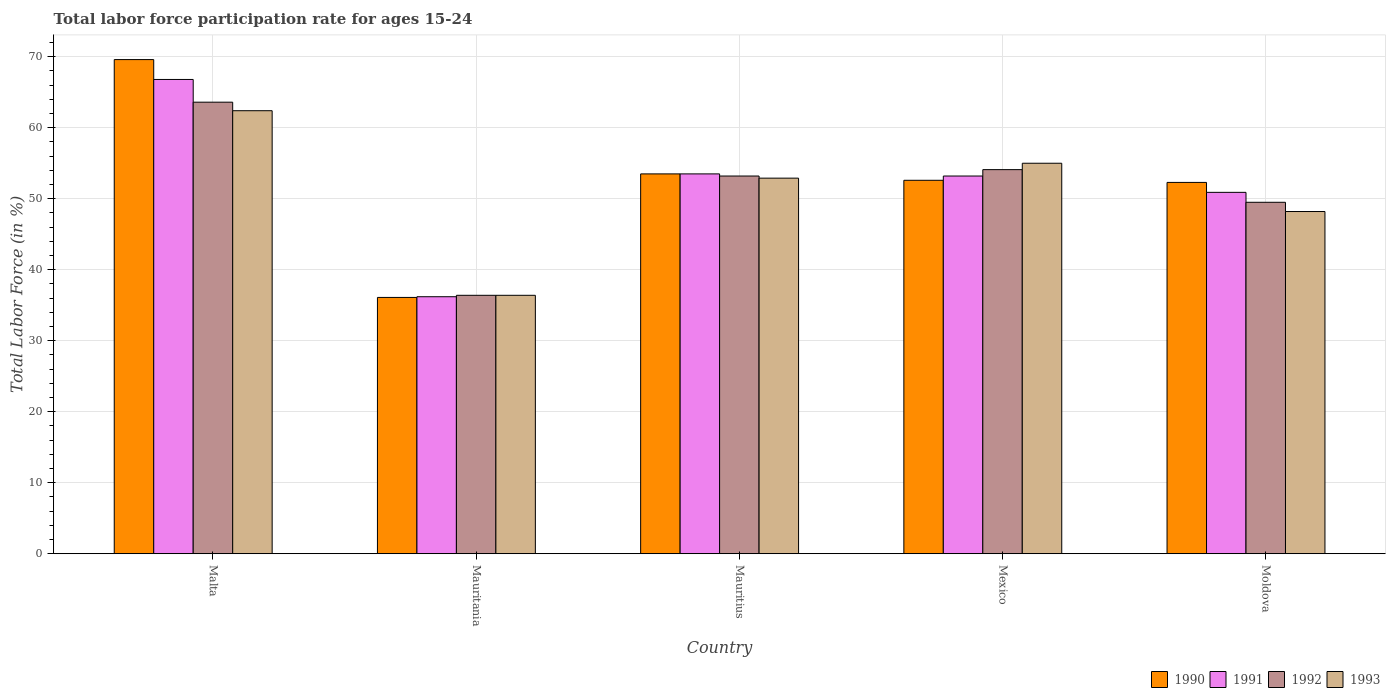How many groups of bars are there?
Ensure brevity in your answer.  5. Are the number of bars per tick equal to the number of legend labels?
Your answer should be compact. Yes. How many bars are there on the 3rd tick from the right?
Offer a very short reply. 4. What is the label of the 1st group of bars from the left?
Keep it short and to the point. Malta. In how many cases, is the number of bars for a given country not equal to the number of legend labels?
Provide a succinct answer. 0. What is the labor force participation rate in 1990 in Mauritius?
Your answer should be compact. 53.5. Across all countries, what is the maximum labor force participation rate in 1990?
Make the answer very short. 69.6. Across all countries, what is the minimum labor force participation rate in 1991?
Provide a short and direct response. 36.2. In which country was the labor force participation rate in 1990 maximum?
Keep it short and to the point. Malta. In which country was the labor force participation rate in 1992 minimum?
Provide a succinct answer. Mauritania. What is the total labor force participation rate in 1991 in the graph?
Provide a short and direct response. 260.6. What is the difference between the labor force participation rate in 1991 in Mauritania and that in Mexico?
Offer a very short reply. -17. What is the average labor force participation rate in 1993 per country?
Offer a very short reply. 50.98. What is the difference between the labor force participation rate of/in 1992 and labor force participation rate of/in 1990 in Mauritius?
Give a very brief answer. -0.3. What is the ratio of the labor force participation rate in 1993 in Malta to that in Mauritius?
Your answer should be very brief. 1.18. Is the labor force participation rate in 1993 in Malta less than that in Mauritania?
Offer a very short reply. No. Is the difference between the labor force participation rate in 1992 in Mauritius and Moldova greater than the difference between the labor force participation rate in 1990 in Mauritius and Moldova?
Provide a succinct answer. Yes. What is the difference between the highest and the second highest labor force participation rate in 1990?
Your answer should be compact. 0.9. Is it the case that in every country, the sum of the labor force participation rate in 1991 and labor force participation rate in 1990 is greater than the labor force participation rate in 1992?
Your answer should be compact. Yes. How many bars are there?
Provide a succinct answer. 20. Are all the bars in the graph horizontal?
Provide a succinct answer. No. How many countries are there in the graph?
Keep it short and to the point. 5. What is the difference between two consecutive major ticks on the Y-axis?
Provide a short and direct response. 10. Are the values on the major ticks of Y-axis written in scientific E-notation?
Make the answer very short. No. Does the graph contain any zero values?
Keep it short and to the point. No. Where does the legend appear in the graph?
Make the answer very short. Bottom right. What is the title of the graph?
Offer a very short reply. Total labor force participation rate for ages 15-24. Does "1964" appear as one of the legend labels in the graph?
Give a very brief answer. No. What is the Total Labor Force (in %) of 1990 in Malta?
Provide a succinct answer. 69.6. What is the Total Labor Force (in %) of 1991 in Malta?
Your answer should be very brief. 66.8. What is the Total Labor Force (in %) of 1992 in Malta?
Offer a terse response. 63.6. What is the Total Labor Force (in %) of 1993 in Malta?
Give a very brief answer. 62.4. What is the Total Labor Force (in %) of 1990 in Mauritania?
Ensure brevity in your answer.  36.1. What is the Total Labor Force (in %) in 1991 in Mauritania?
Offer a terse response. 36.2. What is the Total Labor Force (in %) of 1992 in Mauritania?
Provide a short and direct response. 36.4. What is the Total Labor Force (in %) in 1993 in Mauritania?
Your answer should be compact. 36.4. What is the Total Labor Force (in %) of 1990 in Mauritius?
Provide a short and direct response. 53.5. What is the Total Labor Force (in %) of 1991 in Mauritius?
Your answer should be compact. 53.5. What is the Total Labor Force (in %) of 1992 in Mauritius?
Offer a terse response. 53.2. What is the Total Labor Force (in %) in 1993 in Mauritius?
Offer a very short reply. 52.9. What is the Total Labor Force (in %) of 1990 in Mexico?
Ensure brevity in your answer.  52.6. What is the Total Labor Force (in %) of 1991 in Mexico?
Give a very brief answer. 53.2. What is the Total Labor Force (in %) in 1992 in Mexico?
Make the answer very short. 54.1. What is the Total Labor Force (in %) of 1993 in Mexico?
Your answer should be very brief. 55. What is the Total Labor Force (in %) of 1990 in Moldova?
Your answer should be very brief. 52.3. What is the Total Labor Force (in %) of 1991 in Moldova?
Make the answer very short. 50.9. What is the Total Labor Force (in %) in 1992 in Moldova?
Offer a terse response. 49.5. What is the Total Labor Force (in %) of 1993 in Moldova?
Your answer should be compact. 48.2. Across all countries, what is the maximum Total Labor Force (in %) in 1990?
Your answer should be compact. 69.6. Across all countries, what is the maximum Total Labor Force (in %) in 1991?
Offer a very short reply. 66.8. Across all countries, what is the maximum Total Labor Force (in %) of 1992?
Offer a very short reply. 63.6. Across all countries, what is the maximum Total Labor Force (in %) of 1993?
Ensure brevity in your answer.  62.4. Across all countries, what is the minimum Total Labor Force (in %) of 1990?
Provide a short and direct response. 36.1. Across all countries, what is the minimum Total Labor Force (in %) of 1991?
Your answer should be very brief. 36.2. Across all countries, what is the minimum Total Labor Force (in %) in 1992?
Provide a short and direct response. 36.4. Across all countries, what is the minimum Total Labor Force (in %) of 1993?
Offer a very short reply. 36.4. What is the total Total Labor Force (in %) of 1990 in the graph?
Your response must be concise. 264.1. What is the total Total Labor Force (in %) of 1991 in the graph?
Your answer should be compact. 260.6. What is the total Total Labor Force (in %) of 1992 in the graph?
Your answer should be compact. 256.8. What is the total Total Labor Force (in %) in 1993 in the graph?
Provide a succinct answer. 254.9. What is the difference between the Total Labor Force (in %) of 1990 in Malta and that in Mauritania?
Your answer should be very brief. 33.5. What is the difference between the Total Labor Force (in %) of 1991 in Malta and that in Mauritania?
Make the answer very short. 30.6. What is the difference between the Total Labor Force (in %) in 1992 in Malta and that in Mauritania?
Give a very brief answer. 27.2. What is the difference between the Total Labor Force (in %) of 1993 in Malta and that in Mauritania?
Your answer should be very brief. 26. What is the difference between the Total Labor Force (in %) of 1992 in Malta and that in Mauritius?
Provide a succinct answer. 10.4. What is the difference between the Total Labor Force (in %) of 1990 in Malta and that in Mexico?
Offer a very short reply. 17. What is the difference between the Total Labor Force (in %) in 1992 in Malta and that in Mexico?
Give a very brief answer. 9.5. What is the difference between the Total Labor Force (in %) in 1993 in Malta and that in Mexico?
Your answer should be compact. 7.4. What is the difference between the Total Labor Force (in %) in 1990 in Malta and that in Moldova?
Ensure brevity in your answer.  17.3. What is the difference between the Total Labor Force (in %) in 1991 in Malta and that in Moldova?
Give a very brief answer. 15.9. What is the difference between the Total Labor Force (in %) of 1992 in Malta and that in Moldova?
Offer a terse response. 14.1. What is the difference between the Total Labor Force (in %) of 1993 in Malta and that in Moldova?
Make the answer very short. 14.2. What is the difference between the Total Labor Force (in %) in 1990 in Mauritania and that in Mauritius?
Your answer should be very brief. -17.4. What is the difference between the Total Labor Force (in %) in 1991 in Mauritania and that in Mauritius?
Your response must be concise. -17.3. What is the difference between the Total Labor Force (in %) of 1992 in Mauritania and that in Mauritius?
Provide a succinct answer. -16.8. What is the difference between the Total Labor Force (in %) of 1993 in Mauritania and that in Mauritius?
Your answer should be very brief. -16.5. What is the difference between the Total Labor Force (in %) in 1990 in Mauritania and that in Mexico?
Ensure brevity in your answer.  -16.5. What is the difference between the Total Labor Force (in %) in 1992 in Mauritania and that in Mexico?
Keep it short and to the point. -17.7. What is the difference between the Total Labor Force (in %) of 1993 in Mauritania and that in Mexico?
Give a very brief answer. -18.6. What is the difference between the Total Labor Force (in %) of 1990 in Mauritania and that in Moldova?
Your response must be concise. -16.2. What is the difference between the Total Labor Force (in %) of 1991 in Mauritania and that in Moldova?
Ensure brevity in your answer.  -14.7. What is the difference between the Total Labor Force (in %) of 1992 in Mauritania and that in Moldova?
Your answer should be compact. -13.1. What is the difference between the Total Labor Force (in %) in 1993 in Mauritania and that in Moldova?
Your answer should be compact. -11.8. What is the difference between the Total Labor Force (in %) of 1991 in Mauritius and that in Mexico?
Make the answer very short. 0.3. What is the difference between the Total Labor Force (in %) in 1992 in Mauritius and that in Mexico?
Offer a very short reply. -0.9. What is the difference between the Total Labor Force (in %) in 1990 in Mauritius and that in Moldova?
Your answer should be compact. 1.2. What is the difference between the Total Labor Force (in %) of 1990 in Mexico and that in Moldova?
Provide a succinct answer. 0.3. What is the difference between the Total Labor Force (in %) of 1992 in Mexico and that in Moldova?
Make the answer very short. 4.6. What is the difference between the Total Labor Force (in %) of 1993 in Mexico and that in Moldova?
Your answer should be compact. 6.8. What is the difference between the Total Labor Force (in %) of 1990 in Malta and the Total Labor Force (in %) of 1991 in Mauritania?
Offer a very short reply. 33.4. What is the difference between the Total Labor Force (in %) of 1990 in Malta and the Total Labor Force (in %) of 1992 in Mauritania?
Provide a short and direct response. 33.2. What is the difference between the Total Labor Force (in %) of 1990 in Malta and the Total Labor Force (in %) of 1993 in Mauritania?
Your answer should be compact. 33.2. What is the difference between the Total Labor Force (in %) in 1991 in Malta and the Total Labor Force (in %) in 1992 in Mauritania?
Keep it short and to the point. 30.4. What is the difference between the Total Labor Force (in %) of 1991 in Malta and the Total Labor Force (in %) of 1993 in Mauritania?
Your response must be concise. 30.4. What is the difference between the Total Labor Force (in %) in 1992 in Malta and the Total Labor Force (in %) in 1993 in Mauritania?
Your answer should be compact. 27.2. What is the difference between the Total Labor Force (in %) in 1990 in Malta and the Total Labor Force (in %) in 1992 in Mauritius?
Offer a very short reply. 16.4. What is the difference between the Total Labor Force (in %) in 1991 in Malta and the Total Labor Force (in %) in 1993 in Mauritius?
Your response must be concise. 13.9. What is the difference between the Total Labor Force (in %) of 1992 in Malta and the Total Labor Force (in %) of 1993 in Mauritius?
Your answer should be very brief. 10.7. What is the difference between the Total Labor Force (in %) of 1990 in Malta and the Total Labor Force (in %) of 1992 in Mexico?
Offer a terse response. 15.5. What is the difference between the Total Labor Force (in %) of 1990 in Malta and the Total Labor Force (in %) of 1993 in Mexico?
Your answer should be compact. 14.6. What is the difference between the Total Labor Force (in %) in 1991 in Malta and the Total Labor Force (in %) in 1992 in Mexico?
Give a very brief answer. 12.7. What is the difference between the Total Labor Force (in %) in 1992 in Malta and the Total Labor Force (in %) in 1993 in Mexico?
Keep it short and to the point. 8.6. What is the difference between the Total Labor Force (in %) of 1990 in Malta and the Total Labor Force (in %) of 1992 in Moldova?
Make the answer very short. 20.1. What is the difference between the Total Labor Force (in %) of 1990 in Malta and the Total Labor Force (in %) of 1993 in Moldova?
Your answer should be very brief. 21.4. What is the difference between the Total Labor Force (in %) of 1991 in Malta and the Total Labor Force (in %) of 1993 in Moldova?
Provide a succinct answer. 18.6. What is the difference between the Total Labor Force (in %) in 1992 in Malta and the Total Labor Force (in %) in 1993 in Moldova?
Provide a short and direct response. 15.4. What is the difference between the Total Labor Force (in %) of 1990 in Mauritania and the Total Labor Force (in %) of 1991 in Mauritius?
Provide a short and direct response. -17.4. What is the difference between the Total Labor Force (in %) of 1990 in Mauritania and the Total Labor Force (in %) of 1992 in Mauritius?
Give a very brief answer. -17.1. What is the difference between the Total Labor Force (in %) in 1990 in Mauritania and the Total Labor Force (in %) in 1993 in Mauritius?
Provide a succinct answer. -16.8. What is the difference between the Total Labor Force (in %) of 1991 in Mauritania and the Total Labor Force (in %) of 1993 in Mauritius?
Your answer should be very brief. -16.7. What is the difference between the Total Labor Force (in %) of 1992 in Mauritania and the Total Labor Force (in %) of 1993 in Mauritius?
Make the answer very short. -16.5. What is the difference between the Total Labor Force (in %) in 1990 in Mauritania and the Total Labor Force (in %) in 1991 in Mexico?
Give a very brief answer. -17.1. What is the difference between the Total Labor Force (in %) of 1990 in Mauritania and the Total Labor Force (in %) of 1993 in Mexico?
Your answer should be compact. -18.9. What is the difference between the Total Labor Force (in %) of 1991 in Mauritania and the Total Labor Force (in %) of 1992 in Mexico?
Your response must be concise. -17.9. What is the difference between the Total Labor Force (in %) of 1991 in Mauritania and the Total Labor Force (in %) of 1993 in Mexico?
Keep it short and to the point. -18.8. What is the difference between the Total Labor Force (in %) of 1992 in Mauritania and the Total Labor Force (in %) of 1993 in Mexico?
Your answer should be very brief. -18.6. What is the difference between the Total Labor Force (in %) of 1990 in Mauritania and the Total Labor Force (in %) of 1991 in Moldova?
Ensure brevity in your answer.  -14.8. What is the difference between the Total Labor Force (in %) of 1990 in Mauritania and the Total Labor Force (in %) of 1992 in Moldova?
Provide a succinct answer. -13.4. What is the difference between the Total Labor Force (in %) of 1990 in Mauritania and the Total Labor Force (in %) of 1993 in Moldova?
Keep it short and to the point. -12.1. What is the difference between the Total Labor Force (in %) of 1992 in Mauritania and the Total Labor Force (in %) of 1993 in Moldova?
Make the answer very short. -11.8. What is the difference between the Total Labor Force (in %) of 1990 in Mauritius and the Total Labor Force (in %) of 1991 in Mexico?
Offer a very short reply. 0.3. What is the difference between the Total Labor Force (in %) in 1991 in Mauritius and the Total Labor Force (in %) in 1992 in Mexico?
Your answer should be compact. -0.6. What is the difference between the Total Labor Force (in %) of 1991 in Mauritius and the Total Labor Force (in %) of 1993 in Mexico?
Provide a succinct answer. -1.5. What is the difference between the Total Labor Force (in %) in 1990 in Mauritius and the Total Labor Force (in %) in 1991 in Moldova?
Your response must be concise. 2.6. What is the difference between the Total Labor Force (in %) in 1990 in Mauritius and the Total Labor Force (in %) in 1992 in Moldova?
Offer a very short reply. 4. What is the difference between the Total Labor Force (in %) in 1991 in Mauritius and the Total Labor Force (in %) in 1993 in Moldova?
Ensure brevity in your answer.  5.3. What is the difference between the Total Labor Force (in %) of 1990 in Mexico and the Total Labor Force (in %) of 1992 in Moldova?
Ensure brevity in your answer.  3.1. What is the difference between the Total Labor Force (in %) in 1992 in Mexico and the Total Labor Force (in %) in 1993 in Moldova?
Give a very brief answer. 5.9. What is the average Total Labor Force (in %) of 1990 per country?
Give a very brief answer. 52.82. What is the average Total Labor Force (in %) of 1991 per country?
Provide a succinct answer. 52.12. What is the average Total Labor Force (in %) of 1992 per country?
Give a very brief answer. 51.36. What is the average Total Labor Force (in %) of 1993 per country?
Offer a very short reply. 50.98. What is the difference between the Total Labor Force (in %) in 1990 and Total Labor Force (in %) in 1991 in Malta?
Make the answer very short. 2.8. What is the difference between the Total Labor Force (in %) of 1990 and Total Labor Force (in %) of 1992 in Malta?
Offer a terse response. 6. What is the difference between the Total Labor Force (in %) in 1991 and Total Labor Force (in %) in 1992 in Malta?
Make the answer very short. 3.2. What is the difference between the Total Labor Force (in %) in 1991 and Total Labor Force (in %) in 1993 in Malta?
Ensure brevity in your answer.  4.4. What is the difference between the Total Labor Force (in %) in 1992 and Total Labor Force (in %) in 1993 in Malta?
Give a very brief answer. 1.2. What is the difference between the Total Labor Force (in %) of 1990 and Total Labor Force (in %) of 1992 in Mauritania?
Make the answer very short. -0.3. What is the difference between the Total Labor Force (in %) of 1991 and Total Labor Force (in %) of 1992 in Mauritania?
Keep it short and to the point. -0.2. What is the difference between the Total Labor Force (in %) in 1991 and Total Labor Force (in %) in 1993 in Mauritania?
Give a very brief answer. -0.2. What is the difference between the Total Labor Force (in %) in 1992 and Total Labor Force (in %) in 1993 in Mauritania?
Ensure brevity in your answer.  0. What is the difference between the Total Labor Force (in %) in 1990 and Total Labor Force (in %) in 1991 in Mauritius?
Ensure brevity in your answer.  0. What is the difference between the Total Labor Force (in %) in 1990 and Total Labor Force (in %) in 1992 in Mauritius?
Provide a succinct answer. 0.3. What is the difference between the Total Labor Force (in %) of 1992 and Total Labor Force (in %) of 1993 in Mauritius?
Your answer should be compact. 0.3. What is the difference between the Total Labor Force (in %) in 1990 and Total Labor Force (in %) in 1991 in Mexico?
Make the answer very short. -0.6. What is the difference between the Total Labor Force (in %) of 1990 and Total Labor Force (in %) of 1992 in Mexico?
Ensure brevity in your answer.  -1.5. What is the ratio of the Total Labor Force (in %) in 1990 in Malta to that in Mauritania?
Give a very brief answer. 1.93. What is the ratio of the Total Labor Force (in %) in 1991 in Malta to that in Mauritania?
Your answer should be very brief. 1.85. What is the ratio of the Total Labor Force (in %) of 1992 in Malta to that in Mauritania?
Your answer should be compact. 1.75. What is the ratio of the Total Labor Force (in %) of 1993 in Malta to that in Mauritania?
Offer a very short reply. 1.71. What is the ratio of the Total Labor Force (in %) of 1990 in Malta to that in Mauritius?
Provide a succinct answer. 1.3. What is the ratio of the Total Labor Force (in %) of 1991 in Malta to that in Mauritius?
Give a very brief answer. 1.25. What is the ratio of the Total Labor Force (in %) of 1992 in Malta to that in Mauritius?
Provide a succinct answer. 1.2. What is the ratio of the Total Labor Force (in %) of 1993 in Malta to that in Mauritius?
Ensure brevity in your answer.  1.18. What is the ratio of the Total Labor Force (in %) in 1990 in Malta to that in Mexico?
Provide a short and direct response. 1.32. What is the ratio of the Total Labor Force (in %) of 1991 in Malta to that in Mexico?
Ensure brevity in your answer.  1.26. What is the ratio of the Total Labor Force (in %) of 1992 in Malta to that in Mexico?
Keep it short and to the point. 1.18. What is the ratio of the Total Labor Force (in %) in 1993 in Malta to that in Mexico?
Offer a very short reply. 1.13. What is the ratio of the Total Labor Force (in %) in 1990 in Malta to that in Moldova?
Your answer should be very brief. 1.33. What is the ratio of the Total Labor Force (in %) in 1991 in Malta to that in Moldova?
Offer a very short reply. 1.31. What is the ratio of the Total Labor Force (in %) in 1992 in Malta to that in Moldova?
Make the answer very short. 1.28. What is the ratio of the Total Labor Force (in %) of 1993 in Malta to that in Moldova?
Offer a terse response. 1.29. What is the ratio of the Total Labor Force (in %) of 1990 in Mauritania to that in Mauritius?
Provide a short and direct response. 0.67. What is the ratio of the Total Labor Force (in %) in 1991 in Mauritania to that in Mauritius?
Ensure brevity in your answer.  0.68. What is the ratio of the Total Labor Force (in %) in 1992 in Mauritania to that in Mauritius?
Make the answer very short. 0.68. What is the ratio of the Total Labor Force (in %) of 1993 in Mauritania to that in Mauritius?
Give a very brief answer. 0.69. What is the ratio of the Total Labor Force (in %) of 1990 in Mauritania to that in Mexico?
Your response must be concise. 0.69. What is the ratio of the Total Labor Force (in %) in 1991 in Mauritania to that in Mexico?
Offer a terse response. 0.68. What is the ratio of the Total Labor Force (in %) of 1992 in Mauritania to that in Mexico?
Your response must be concise. 0.67. What is the ratio of the Total Labor Force (in %) of 1993 in Mauritania to that in Mexico?
Provide a short and direct response. 0.66. What is the ratio of the Total Labor Force (in %) in 1990 in Mauritania to that in Moldova?
Offer a very short reply. 0.69. What is the ratio of the Total Labor Force (in %) in 1991 in Mauritania to that in Moldova?
Make the answer very short. 0.71. What is the ratio of the Total Labor Force (in %) in 1992 in Mauritania to that in Moldova?
Make the answer very short. 0.74. What is the ratio of the Total Labor Force (in %) in 1993 in Mauritania to that in Moldova?
Give a very brief answer. 0.76. What is the ratio of the Total Labor Force (in %) of 1990 in Mauritius to that in Mexico?
Give a very brief answer. 1.02. What is the ratio of the Total Labor Force (in %) of 1991 in Mauritius to that in Mexico?
Your answer should be very brief. 1.01. What is the ratio of the Total Labor Force (in %) in 1992 in Mauritius to that in Mexico?
Keep it short and to the point. 0.98. What is the ratio of the Total Labor Force (in %) of 1993 in Mauritius to that in Mexico?
Offer a terse response. 0.96. What is the ratio of the Total Labor Force (in %) in 1990 in Mauritius to that in Moldova?
Keep it short and to the point. 1.02. What is the ratio of the Total Labor Force (in %) of 1991 in Mauritius to that in Moldova?
Your answer should be compact. 1.05. What is the ratio of the Total Labor Force (in %) in 1992 in Mauritius to that in Moldova?
Give a very brief answer. 1.07. What is the ratio of the Total Labor Force (in %) in 1993 in Mauritius to that in Moldova?
Provide a short and direct response. 1.1. What is the ratio of the Total Labor Force (in %) of 1990 in Mexico to that in Moldova?
Keep it short and to the point. 1.01. What is the ratio of the Total Labor Force (in %) in 1991 in Mexico to that in Moldova?
Make the answer very short. 1.05. What is the ratio of the Total Labor Force (in %) of 1992 in Mexico to that in Moldova?
Make the answer very short. 1.09. What is the ratio of the Total Labor Force (in %) in 1993 in Mexico to that in Moldova?
Offer a terse response. 1.14. What is the difference between the highest and the lowest Total Labor Force (in %) of 1990?
Provide a short and direct response. 33.5. What is the difference between the highest and the lowest Total Labor Force (in %) of 1991?
Keep it short and to the point. 30.6. What is the difference between the highest and the lowest Total Labor Force (in %) of 1992?
Provide a short and direct response. 27.2. 